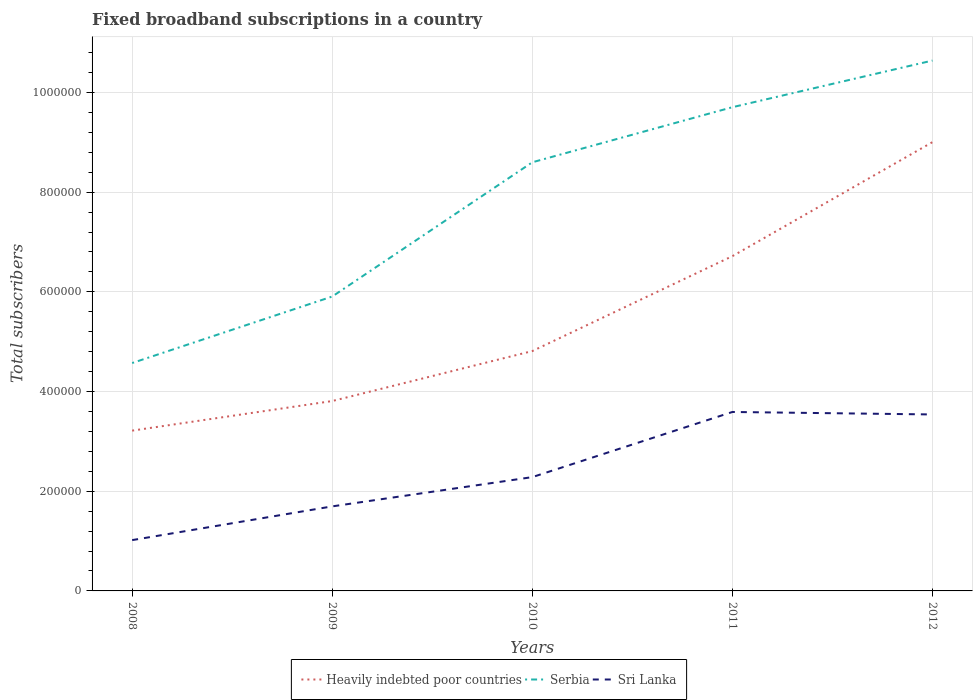How many different coloured lines are there?
Offer a very short reply. 3. Across all years, what is the maximum number of broadband subscriptions in Heavily indebted poor countries?
Ensure brevity in your answer.  3.22e+05. What is the total number of broadband subscriptions in Sri Lanka in the graph?
Ensure brevity in your answer.  -1.26e+05. What is the difference between the highest and the second highest number of broadband subscriptions in Serbia?
Offer a very short reply. 6.07e+05. How many lines are there?
Make the answer very short. 3. How many years are there in the graph?
Ensure brevity in your answer.  5. Does the graph contain any zero values?
Provide a succinct answer. No. Does the graph contain grids?
Give a very brief answer. Yes. How many legend labels are there?
Provide a short and direct response. 3. How are the legend labels stacked?
Your answer should be compact. Horizontal. What is the title of the graph?
Your answer should be very brief. Fixed broadband subscriptions in a country. Does "Cote d'Ivoire" appear as one of the legend labels in the graph?
Your answer should be compact. No. What is the label or title of the Y-axis?
Ensure brevity in your answer.  Total subscribers. What is the Total subscribers in Heavily indebted poor countries in 2008?
Your answer should be compact. 3.22e+05. What is the Total subscribers in Serbia in 2008?
Your answer should be very brief. 4.57e+05. What is the Total subscribers of Sri Lanka in 2008?
Provide a short and direct response. 1.02e+05. What is the Total subscribers in Heavily indebted poor countries in 2009?
Ensure brevity in your answer.  3.81e+05. What is the Total subscribers in Serbia in 2009?
Your answer should be very brief. 5.91e+05. What is the Total subscribers in Sri Lanka in 2009?
Make the answer very short. 1.70e+05. What is the Total subscribers in Heavily indebted poor countries in 2010?
Your answer should be compact. 4.81e+05. What is the Total subscribers of Serbia in 2010?
Make the answer very short. 8.60e+05. What is the Total subscribers in Sri Lanka in 2010?
Provide a short and direct response. 2.28e+05. What is the Total subscribers in Heavily indebted poor countries in 2011?
Give a very brief answer. 6.72e+05. What is the Total subscribers in Serbia in 2011?
Offer a very short reply. 9.70e+05. What is the Total subscribers in Sri Lanka in 2011?
Offer a very short reply. 3.59e+05. What is the Total subscribers in Heavily indebted poor countries in 2012?
Ensure brevity in your answer.  9.00e+05. What is the Total subscribers in Serbia in 2012?
Ensure brevity in your answer.  1.06e+06. What is the Total subscribers of Sri Lanka in 2012?
Your answer should be very brief. 3.54e+05. Across all years, what is the maximum Total subscribers in Heavily indebted poor countries?
Make the answer very short. 9.00e+05. Across all years, what is the maximum Total subscribers in Serbia?
Offer a very short reply. 1.06e+06. Across all years, what is the maximum Total subscribers of Sri Lanka?
Make the answer very short. 3.59e+05. Across all years, what is the minimum Total subscribers in Heavily indebted poor countries?
Make the answer very short. 3.22e+05. Across all years, what is the minimum Total subscribers of Serbia?
Provide a short and direct response. 4.57e+05. Across all years, what is the minimum Total subscribers of Sri Lanka?
Your answer should be compact. 1.02e+05. What is the total Total subscribers in Heavily indebted poor countries in the graph?
Ensure brevity in your answer.  2.76e+06. What is the total Total subscribers of Serbia in the graph?
Make the answer very short. 3.94e+06. What is the total Total subscribers in Sri Lanka in the graph?
Make the answer very short. 1.21e+06. What is the difference between the Total subscribers of Heavily indebted poor countries in 2008 and that in 2009?
Make the answer very short. -5.94e+04. What is the difference between the Total subscribers in Serbia in 2008 and that in 2009?
Keep it short and to the point. -1.33e+05. What is the difference between the Total subscribers in Sri Lanka in 2008 and that in 2009?
Your answer should be compact. -6.77e+04. What is the difference between the Total subscribers in Heavily indebted poor countries in 2008 and that in 2010?
Provide a short and direct response. -1.60e+05. What is the difference between the Total subscribers in Serbia in 2008 and that in 2010?
Make the answer very short. -4.03e+05. What is the difference between the Total subscribers of Sri Lanka in 2008 and that in 2010?
Keep it short and to the point. -1.26e+05. What is the difference between the Total subscribers in Heavily indebted poor countries in 2008 and that in 2011?
Keep it short and to the point. -3.50e+05. What is the difference between the Total subscribers in Serbia in 2008 and that in 2011?
Your answer should be very brief. -5.13e+05. What is the difference between the Total subscribers of Sri Lanka in 2008 and that in 2011?
Ensure brevity in your answer.  -2.57e+05. What is the difference between the Total subscribers of Heavily indebted poor countries in 2008 and that in 2012?
Make the answer very short. -5.79e+05. What is the difference between the Total subscribers in Serbia in 2008 and that in 2012?
Your response must be concise. -6.07e+05. What is the difference between the Total subscribers in Sri Lanka in 2008 and that in 2012?
Your response must be concise. -2.52e+05. What is the difference between the Total subscribers in Heavily indebted poor countries in 2009 and that in 2010?
Your response must be concise. -1.00e+05. What is the difference between the Total subscribers in Serbia in 2009 and that in 2010?
Make the answer very short. -2.69e+05. What is the difference between the Total subscribers in Sri Lanka in 2009 and that in 2010?
Keep it short and to the point. -5.87e+04. What is the difference between the Total subscribers of Heavily indebted poor countries in 2009 and that in 2011?
Your answer should be very brief. -2.91e+05. What is the difference between the Total subscribers of Serbia in 2009 and that in 2011?
Keep it short and to the point. -3.80e+05. What is the difference between the Total subscribers in Sri Lanka in 2009 and that in 2011?
Provide a short and direct response. -1.89e+05. What is the difference between the Total subscribers of Heavily indebted poor countries in 2009 and that in 2012?
Keep it short and to the point. -5.19e+05. What is the difference between the Total subscribers in Serbia in 2009 and that in 2012?
Your response must be concise. -4.73e+05. What is the difference between the Total subscribers of Sri Lanka in 2009 and that in 2012?
Make the answer very short. -1.84e+05. What is the difference between the Total subscribers of Heavily indebted poor countries in 2010 and that in 2011?
Offer a very short reply. -1.90e+05. What is the difference between the Total subscribers of Serbia in 2010 and that in 2011?
Keep it short and to the point. -1.11e+05. What is the difference between the Total subscribers in Sri Lanka in 2010 and that in 2011?
Offer a very short reply. -1.31e+05. What is the difference between the Total subscribers of Heavily indebted poor countries in 2010 and that in 2012?
Your answer should be very brief. -4.19e+05. What is the difference between the Total subscribers in Serbia in 2010 and that in 2012?
Your answer should be very brief. -2.04e+05. What is the difference between the Total subscribers in Sri Lanka in 2010 and that in 2012?
Provide a succinct answer. -1.26e+05. What is the difference between the Total subscribers in Heavily indebted poor countries in 2011 and that in 2012?
Your answer should be compact. -2.29e+05. What is the difference between the Total subscribers in Serbia in 2011 and that in 2012?
Ensure brevity in your answer.  -9.36e+04. What is the difference between the Total subscribers of Sri Lanka in 2011 and that in 2012?
Make the answer very short. 5000. What is the difference between the Total subscribers of Heavily indebted poor countries in 2008 and the Total subscribers of Serbia in 2009?
Provide a succinct answer. -2.69e+05. What is the difference between the Total subscribers in Heavily indebted poor countries in 2008 and the Total subscribers in Sri Lanka in 2009?
Keep it short and to the point. 1.52e+05. What is the difference between the Total subscribers of Serbia in 2008 and the Total subscribers of Sri Lanka in 2009?
Your response must be concise. 2.88e+05. What is the difference between the Total subscribers in Heavily indebted poor countries in 2008 and the Total subscribers in Serbia in 2010?
Your answer should be very brief. -5.38e+05. What is the difference between the Total subscribers in Heavily indebted poor countries in 2008 and the Total subscribers in Sri Lanka in 2010?
Offer a very short reply. 9.33e+04. What is the difference between the Total subscribers in Serbia in 2008 and the Total subscribers in Sri Lanka in 2010?
Ensure brevity in your answer.  2.29e+05. What is the difference between the Total subscribers of Heavily indebted poor countries in 2008 and the Total subscribers of Serbia in 2011?
Keep it short and to the point. -6.49e+05. What is the difference between the Total subscribers of Heavily indebted poor countries in 2008 and the Total subscribers of Sri Lanka in 2011?
Keep it short and to the point. -3.74e+04. What is the difference between the Total subscribers in Serbia in 2008 and the Total subscribers in Sri Lanka in 2011?
Provide a short and direct response. 9.82e+04. What is the difference between the Total subscribers of Heavily indebted poor countries in 2008 and the Total subscribers of Serbia in 2012?
Offer a very short reply. -7.42e+05. What is the difference between the Total subscribers of Heavily indebted poor countries in 2008 and the Total subscribers of Sri Lanka in 2012?
Keep it short and to the point. -3.24e+04. What is the difference between the Total subscribers in Serbia in 2008 and the Total subscribers in Sri Lanka in 2012?
Ensure brevity in your answer.  1.03e+05. What is the difference between the Total subscribers in Heavily indebted poor countries in 2009 and the Total subscribers in Serbia in 2010?
Offer a very short reply. -4.79e+05. What is the difference between the Total subscribers of Heavily indebted poor countries in 2009 and the Total subscribers of Sri Lanka in 2010?
Provide a short and direct response. 1.53e+05. What is the difference between the Total subscribers of Serbia in 2009 and the Total subscribers of Sri Lanka in 2010?
Your answer should be very brief. 3.62e+05. What is the difference between the Total subscribers in Heavily indebted poor countries in 2009 and the Total subscribers in Serbia in 2011?
Offer a terse response. -5.89e+05. What is the difference between the Total subscribers in Heavily indebted poor countries in 2009 and the Total subscribers in Sri Lanka in 2011?
Provide a short and direct response. 2.19e+04. What is the difference between the Total subscribers of Serbia in 2009 and the Total subscribers of Sri Lanka in 2011?
Your answer should be compact. 2.32e+05. What is the difference between the Total subscribers in Heavily indebted poor countries in 2009 and the Total subscribers in Serbia in 2012?
Make the answer very short. -6.83e+05. What is the difference between the Total subscribers of Heavily indebted poor countries in 2009 and the Total subscribers of Sri Lanka in 2012?
Make the answer very short. 2.69e+04. What is the difference between the Total subscribers in Serbia in 2009 and the Total subscribers in Sri Lanka in 2012?
Keep it short and to the point. 2.37e+05. What is the difference between the Total subscribers in Heavily indebted poor countries in 2010 and the Total subscribers in Serbia in 2011?
Your answer should be compact. -4.89e+05. What is the difference between the Total subscribers in Heavily indebted poor countries in 2010 and the Total subscribers in Sri Lanka in 2011?
Make the answer very short. 1.22e+05. What is the difference between the Total subscribers in Serbia in 2010 and the Total subscribers in Sri Lanka in 2011?
Ensure brevity in your answer.  5.01e+05. What is the difference between the Total subscribers of Heavily indebted poor countries in 2010 and the Total subscribers of Serbia in 2012?
Make the answer very short. -5.83e+05. What is the difference between the Total subscribers of Heavily indebted poor countries in 2010 and the Total subscribers of Sri Lanka in 2012?
Offer a very short reply. 1.27e+05. What is the difference between the Total subscribers in Serbia in 2010 and the Total subscribers in Sri Lanka in 2012?
Your response must be concise. 5.06e+05. What is the difference between the Total subscribers of Heavily indebted poor countries in 2011 and the Total subscribers of Serbia in 2012?
Provide a short and direct response. -3.92e+05. What is the difference between the Total subscribers of Heavily indebted poor countries in 2011 and the Total subscribers of Sri Lanka in 2012?
Give a very brief answer. 3.18e+05. What is the difference between the Total subscribers in Serbia in 2011 and the Total subscribers in Sri Lanka in 2012?
Your answer should be very brief. 6.16e+05. What is the average Total subscribers in Heavily indebted poor countries per year?
Make the answer very short. 5.51e+05. What is the average Total subscribers of Serbia per year?
Your answer should be very brief. 7.88e+05. What is the average Total subscribers of Sri Lanka per year?
Ensure brevity in your answer.  2.43e+05. In the year 2008, what is the difference between the Total subscribers of Heavily indebted poor countries and Total subscribers of Serbia?
Your answer should be very brief. -1.36e+05. In the year 2008, what is the difference between the Total subscribers in Heavily indebted poor countries and Total subscribers in Sri Lanka?
Your answer should be very brief. 2.20e+05. In the year 2008, what is the difference between the Total subscribers in Serbia and Total subscribers in Sri Lanka?
Your response must be concise. 3.55e+05. In the year 2009, what is the difference between the Total subscribers in Heavily indebted poor countries and Total subscribers in Serbia?
Your answer should be compact. -2.10e+05. In the year 2009, what is the difference between the Total subscribers of Heavily indebted poor countries and Total subscribers of Sri Lanka?
Offer a very short reply. 2.11e+05. In the year 2009, what is the difference between the Total subscribers in Serbia and Total subscribers in Sri Lanka?
Offer a very short reply. 4.21e+05. In the year 2010, what is the difference between the Total subscribers in Heavily indebted poor countries and Total subscribers in Serbia?
Offer a terse response. -3.79e+05. In the year 2010, what is the difference between the Total subscribers of Heavily indebted poor countries and Total subscribers of Sri Lanka?
Your response must be concise. 2.53e+05. In the year 2010, what is the difference between the Total subscribers of Serbia and Total subscribers of Sri Lanka?
Ensure brevity in your answer.  6.32e+05. In the year 2011, what is the difference between the Total subscribers of Heavily indebted poor countries and Total subscribers of Serbia?
Offer a very short reply. -2.99e+05. In the year 2011, what is the difference between the Total subscribers in Heavily indebted poor countries and Total subscribers in Sri Lanka?
Your response must be concise. 3.13e+05. In the year 2011, what is the difference between the Total subscribers of Serbia and Total subscribers of Sri Lanka?
Your answer should be compact. 6.11e+05. In the year 2012, what is the difference between the Total subscribers of Heavily indebted poor countries and Total subscribers of Serbia?
Offer a terse response. -1.64e+05. In the year 2012, what is the difference between the Total subscribers in Heavily indebted poor countries and Total subscribers in Sri Lanka?
Make the answer very short. 5.46e+05. In the year 2012, what is the difference between the Total subscribers in Serbia and Total subscribers in Sri Lanka?
Offer a very short reply. 7.10e+05. What is the ratio of the Total subscribers of Heavily indebted poor countries in 2008 to that in 2009?
Provide a short and direct response. 0.84. What is the ratio of the Total subscribers of Serbia in 2008 to that in 2009?
Offer a very short reply. 0.77. What is the ratio of the Total subscribers in Sri Lanka in 2008 to that in 2009?
Keep it short and to the point. 0.6. What is the ratio of the Total subscribers in Heavily indebted poor countries in 2008 to that in 2010?
Offer a terse response. 0.67. What is the ratio of the Total subscribers of Serbia in 2008 to that in 2010?
Your answer should be compact. 0.53. What is the ratio of the Total subscribers of Sri Lanka in 2008 to that in 2010?
Offer a very short reply. 0.45. What is the ratio of the Total subscribers of Heavily indebted poor countries in 2008 to that in 2011?
Provide a succinct answer. 0.48. What is the ratio of the Total subscribers of Serbia in 2008 to that in 2011?
Provide a succinct answer. 0.47. What is the ratio of the Total subscribers of Sri Lanka in 2008 to that in 2011?
Make the answer very short. 0.28. What is the ratio of the Total subscribers of Heavily indebted poor countries in 2008 to that in 2012?
Your answer should be compact. 0.36. What is the ratio of the Total subscribers of Serbia in 2008 to that in 2012?
Your response must be concise. 0.43. What is the ratio of the Total subscribers in Sri Lanka in 2008 to that in 2012?
Keep it short and to the point. 0.29. What is the ratio of the Total subscribers in Heavily indebted poor countries in 2009 to that in 2010?
Your answer should be compact. 0.79. What is the ratio of the Total subscribers in Serbia in 2009 to that in 2010?
Provide a short and direct response. 0.69. What is the ratio of the Total subscribers in Sri Lanka in 2009 to that in 2010?
Your response must be concise. 0.74. What is the ratio of the Total subscribers in Heavily indebted poor countries in 2009 to that in 2011?
Provide a short and direct response. 0.57. What is the ratio of the Total subscribers of Serbia in 2009 to that in 2011?
Your answer should be very brief. 0.61. What is the ratio of the Total subscribers of Sri Lanka in 2009 to that in 2011?
Your answer should be very brief. 0.47. What is the ratio of the Total subscribers in Heavily indebted poor countries in 2009 to that in 2012?
Your answer should be very brief. 0.42. What is the ratio of the Total subscribers in Serbia in 2009 to that in 2012?
Your response must be concise. 0.56. What is the ratio of the Total subscribers in Sri Lanka in 2009 to that in 2012?
Your answer should be compact. 0.48. What is the ratio of the Total subscribers in Heavily indebted poor countries in 2010 to that in 2011?
Ensure brevity in your answer.  0.72. What is the ratio of the Total subscribers of Serbia in 2010 to that in 2011?
Your answer should be very brief. 0.89. What is the ratio of the Total subscribers of Sri Lanka in 2010 to that in 2011?
Make the answer very short. 0.64. What is the ratio of the Total subscribers in Heavily indebted poor countries in 2010 to that in 2012?
Your response must be concise. 0.53. What is the ratio of the Total subscribers in Serbia in 2010 to that in 2012?
Provide a short and direct response. 0.81. What is the ratio of the Total subscribers of Sri Lanka in 2010 to that in 2012?
Keep it short and to the point. 0.65. What is the ratio of the Total subscribers in Heavily indebted poor countries in 2011 to that in 2012?
Offer a terse response. 0.75. What is the ratio of the Total subscribers in Serbia in 2011 to that in 2012?
Your response must be concise. 0.91. What is the ratio of the Total subscribers of Sri Lanka in 2011 to that in 2012?
Your response must be concise. 1.01. What is the difference between the highest and the second highest Total subscribers in Heavily indebted poor countries?
Provide a succinct answer. 2.29e+05. What is the difference between the highest and the second highest Total subscribers of Serbia?
Offer a terse response. 9.36e+04. What is the difference between the highest and the lowest Total subscribers in Heavily indebted poor countries?
Provide a succinct answer. 5.79e+05. What is the difference between the highest and the lowest Total subscribers in Serbia?
Your answer should be compact. 6.07e+05. What is the difference between the highest and the lowest Total subscribers of Sri Lanka?
Your response must be concise. 2.57e+05. 